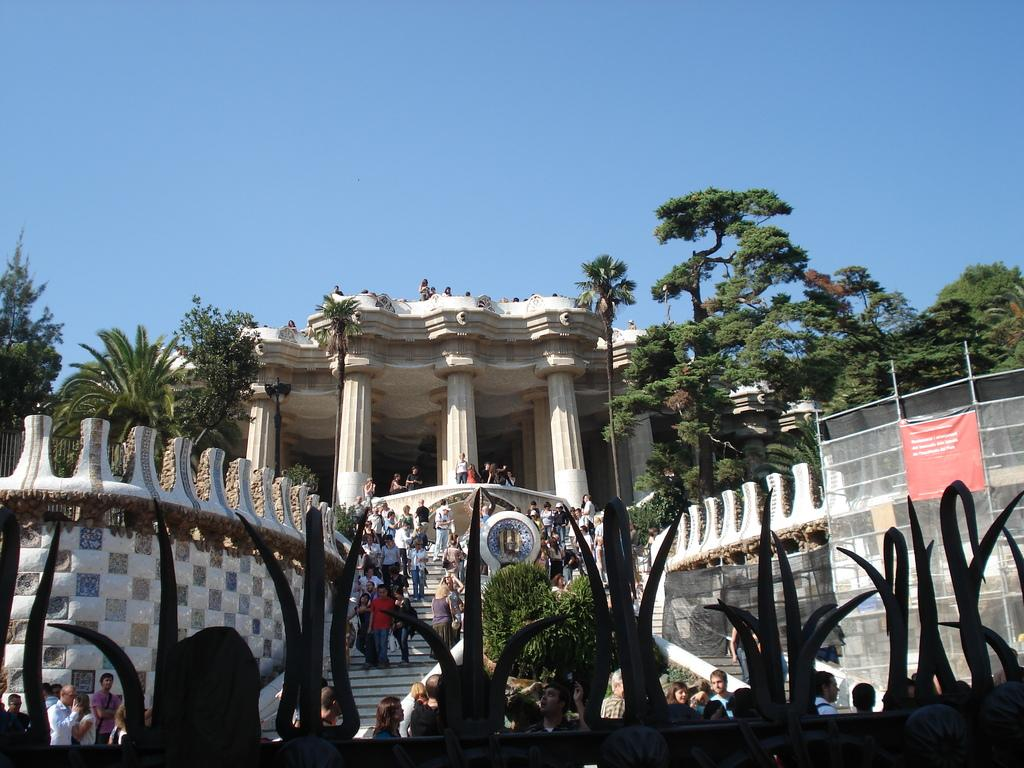What type of structure is visible in the image? There is a building in the image. Who or what else can be seen in the image? There are people in the image. What other natural elements are present in the image? There are trees in the image. What type of bath is being taken by the people in the image? There is no indication of a bath or any bathing activity in the image. 